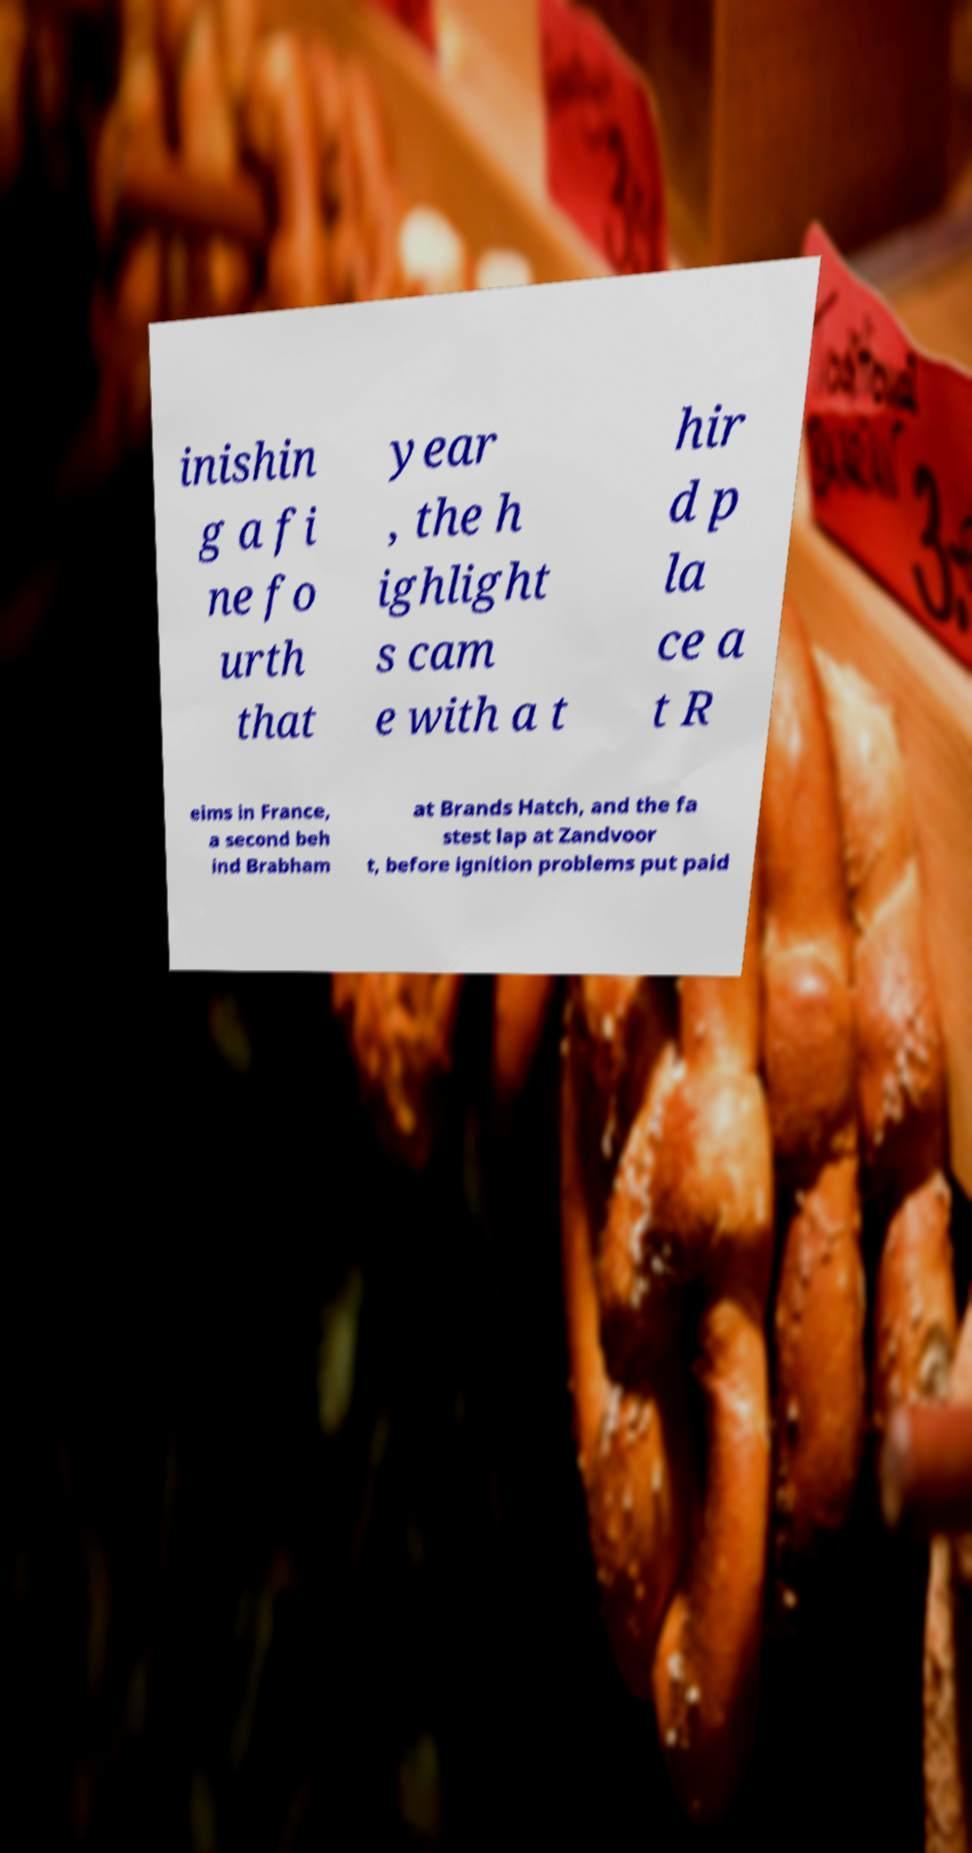There's text embedded in this image that I need extracted. Can you transcribe it verbatim? inishin g a fi ne fo urth that year , the h ighlight s cam e with a t hir d p la ce a t R eims in France, a second beh ind Brabham at Brands Hatch, and the fa stest lap at Zandvoor t, before ignition problems put paid 